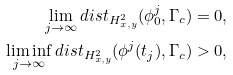Convert formula to latex. <formula><loc_0><loc_0><loc_500><loc_500>\lim _ { j \to \infty } d i s t _ { H _ { x , y } ^ { 2 } } ( \phi _ { 0 } ^ { j } , \Gamma _ { c } ) = 0 , \\ \liminf _ { j \to \infty } d i s t _ { H _ { x , y } ^ { 2 } } ( \phi ^ { j } ( t _ { j } ) , \Gamma _ { c } ) > 0 ,</formula> 